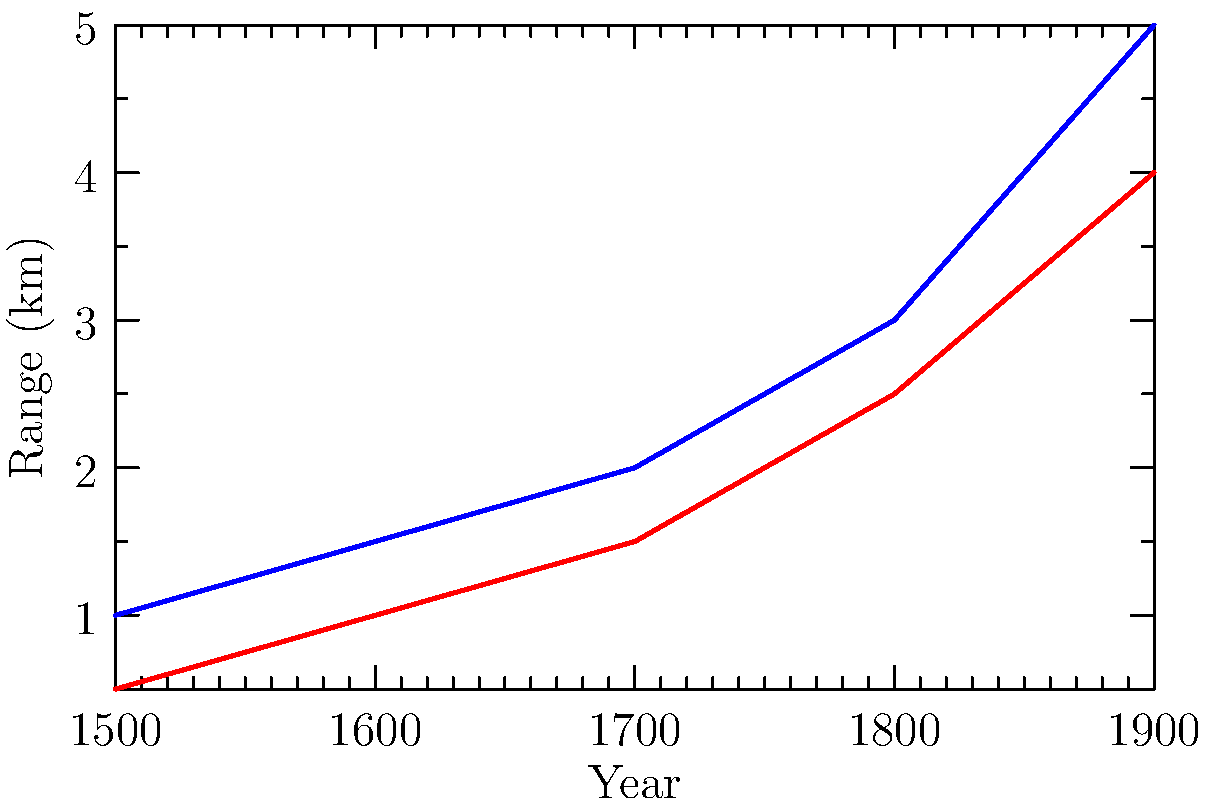Based on the graph showing the range of field and naval artillery over time, which type of artillery consistently demonstrated a greater range, and by approximately what margin in the year 1800? To answer this question, we need to analyze the graph step-by-step:

1. Observe the two lines: blue represents field artillery, and red represents naval artillery.
2. Compare the relative positions of the two lines throughout the time period shown (1500-1900).
3. Notice that the blue line (field artillery) is consistently above the red line (naval artillery).
4. This indicates that field artillery consistently had a greater range than naval artillery.
5. To determine the margin of difference in 1800:
   a. Locate the year 1800 on the x-axis.
   b. Find the corresponding y-values for both types of artillery.
   c. Field artillery (blue line) shows a range of approximately 3 km.
   d. Naval artillery (red line) shows a range of approximately 2.5 km.
   e. Calculate the difference: $3 \text{ km} - 2.5 \text{ km} = 0.5 \text{ km}$

Therefore, field artillery consistently demonstrated a greater range, with a margin of approximately 0.5 km in the year 1800.
Answer: Field artillery; 0.5 km 